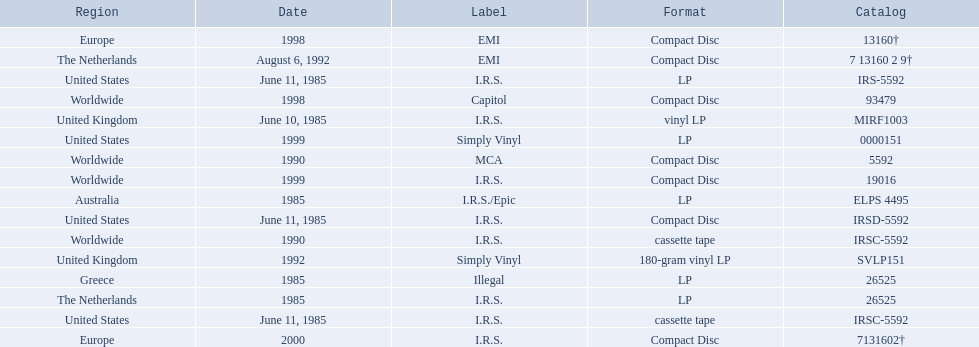What dates were lps of any kind released? June 10, 1985, June 11, 1985, 1985, 1985, 1985, 1992, 1999. In which countries were these released in by i.r.s.? United Kingdom, United States, Australia, The Netherlands. Which of these countries is not in the northern hemisphere? Australia. 